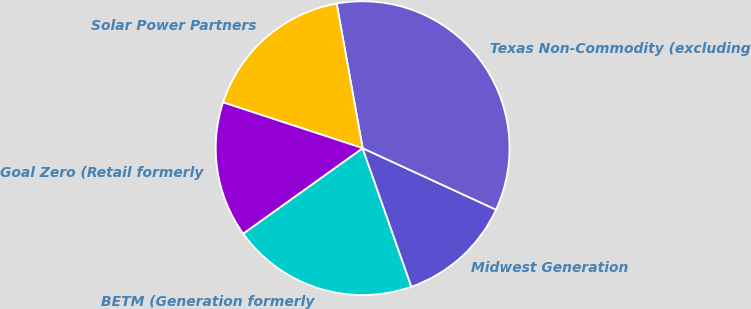<chart> <loc_0><loc_0><loc_500><loc_500><pie_chart><fcel>BETM (Generation formerly<fcel>Midwest Generation<fcel>Texas Non-Commodity (excluding<fcel>Solar Power Partners<fcel>Goal Zero (Retail formerly<nl><fcel>20.5%<fcel>12.74%<fcel>34.7%<fcel>17.13%<fcel>14.93%<nl></chart> 